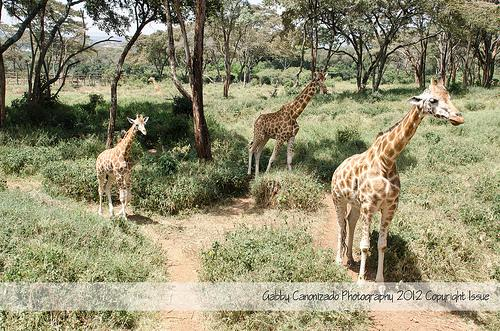Question: why are the giraffes standing in this picture?
Choices:
A. To stretch their legs.
B. They are looking for food.
C. To see over the fence.
D. To get measured.
Answer with the letter. Answer: B Question: where does this picture take place?
Choices:
A. Beach.
B. City.
C. In a grassy field.
D. Indoors.
Answer with the letter. Answer: C Question: what color is the grass?
Choices:
A. Brown.
B. Green.
C. Black.
D. Yellow.
Answer with the letter. Answer: B Question: how many giraffes are in this picture?
Choices:
A. Five.
B. Nine.
C. Three.
D. Four.
Answer with the letter. Answer: D Question: what color are the giraffes?
Choices:
A. Brown and white.
B. Yellow.
C. Brown and yellow.
D. Black.
Answer with the letter. Answer: A 